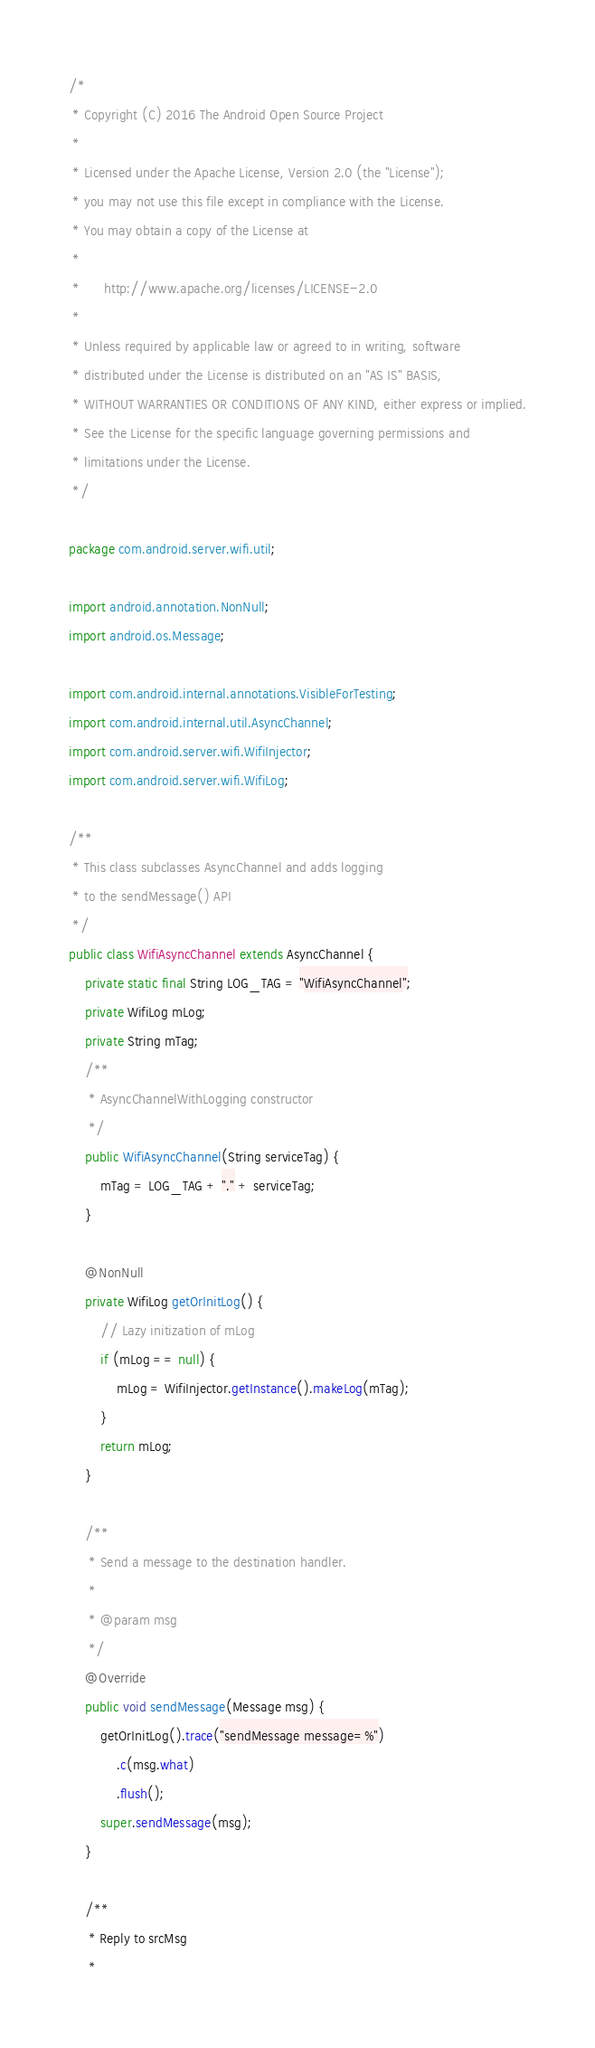<code> <loc_0><loc_0><loc_500><loc_500><_Java_>/*
 * Copyright (C) 2016 The Android Open Source Project
 *
 * Licensed under the Apache License, Version 2.0 (the "License");
 * you may not use this file except in compliance with the License.
 * You may obtain a copy of the License at
 *
 *      http://www.apache.org/licenses/LICENSE-2.0
 *
 * Unless required by applicable law or agreed to in writing, software
 * distributed under the License is distributed on an "AS IS" BASIS,
 * WITHOUT WARRANTIES OR CONDITIONS OF ANY KIND, either express or implied.
 * See the License for the specific language governing permissions and
 * limitations under the License.
 */

package com.android.server.wifi.util;

import android.annotation.NonNull;
import android.os.Message;

import com.android.internal.annotations.VisibleForTesting;
import com.android.internal.util.AsyncChannel;
import com.android.server.wifi.WifiInjector;
import com.android.server.wifi.WifiLog;

/**
 * This class subclasses AsyncChannel and adds logging
 * to the sendMessage() API
 */
public class WifiAsyncChannel extends AsyncChannel {
    private static final String LOG_TAG = "WifiAsyncChannel";
    private WifiLog mLog;
    private String mTag;
    /**
     * AsyncChannelWithLogging constructor
     */
    public WifiAsyncChannel(String serviceTag) {
        mTag = LOG_TAG + "." + serviceTag;
    }

    @NonNull
    private WifiLog getOrInitLog() {
        // Lazy initization of mLog
        if (mLog == null) {
            mLog = WifiInjector.getInstance().makeLog(mTag);
        }
        return mLog;
    }

    /**
     * Send a message to the destination handler.
     *
     * @param msg
     */
    @Override
    public void sendMessage(Message msg) {
        getOrInitLog().trace("sendMessage message=%")
            .c(msg.what)
            .flush();
        super.sendMessage(msg);
    }

    /**
     * Reply to srcMsg
     *</code> 